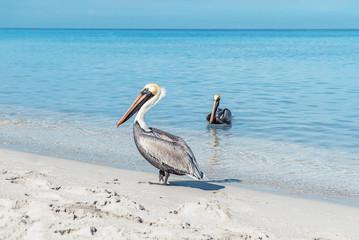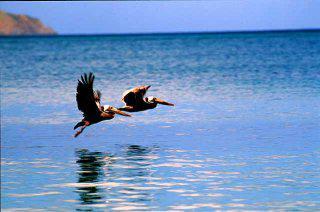The first image is the image on the left, the second image is the image on the right. For the images displayed, is the sentence "One image shows two pelicans in flight above the water, and the other image shows two pelicans that have plunged into the water." factually correct? Answer yes or no. No. The first image is the image on the left, the second image is the image on the right. Assess this claim about the two images: "At least one pelican is diving for food with its head in the water.". Correct or not? Answer yes or no. No. 